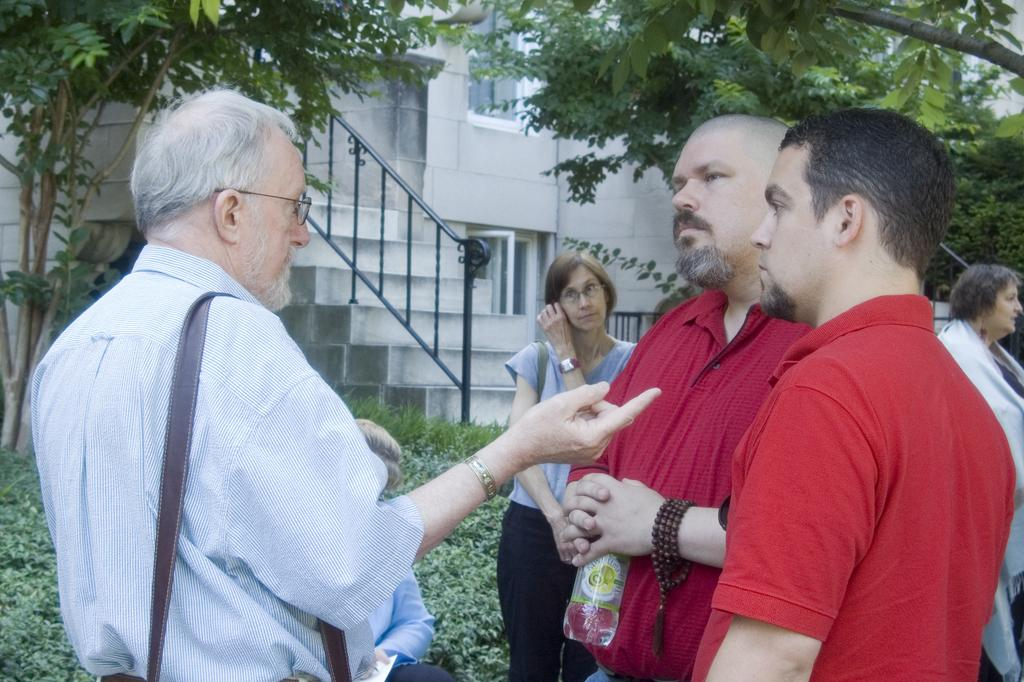What is happening in the middle of the image? There are people standing in the middle of the image. What can be seen in the background of the image? There are plants, trees, and a building in the background of the image. What thought is the plant having in the image? Plants do not have thoughts, as they are inanimate objects. 